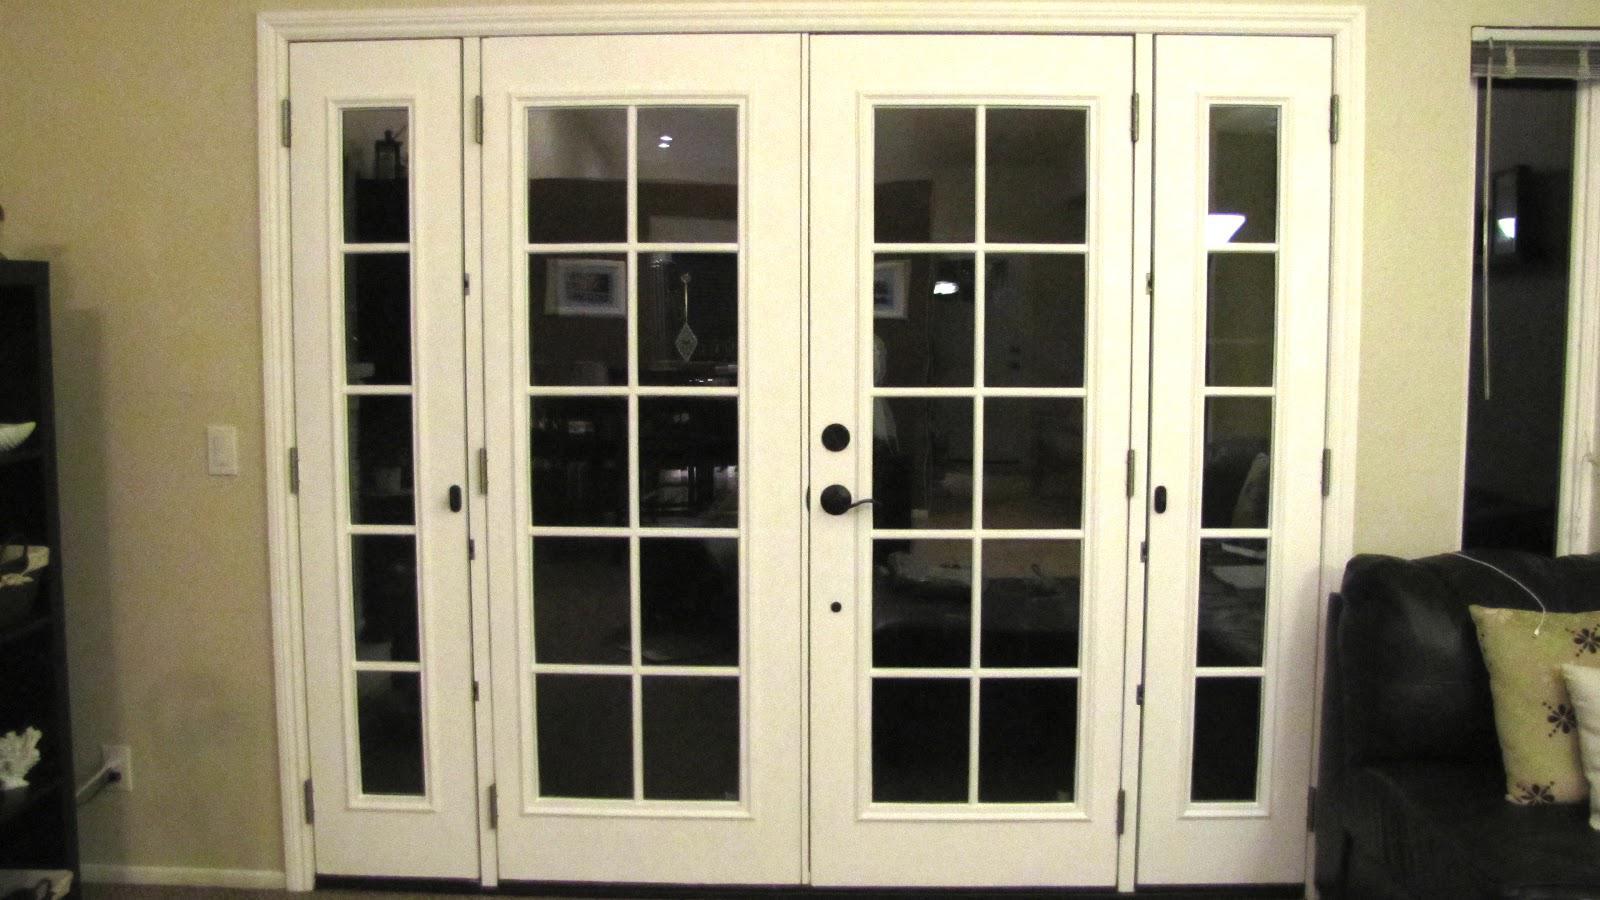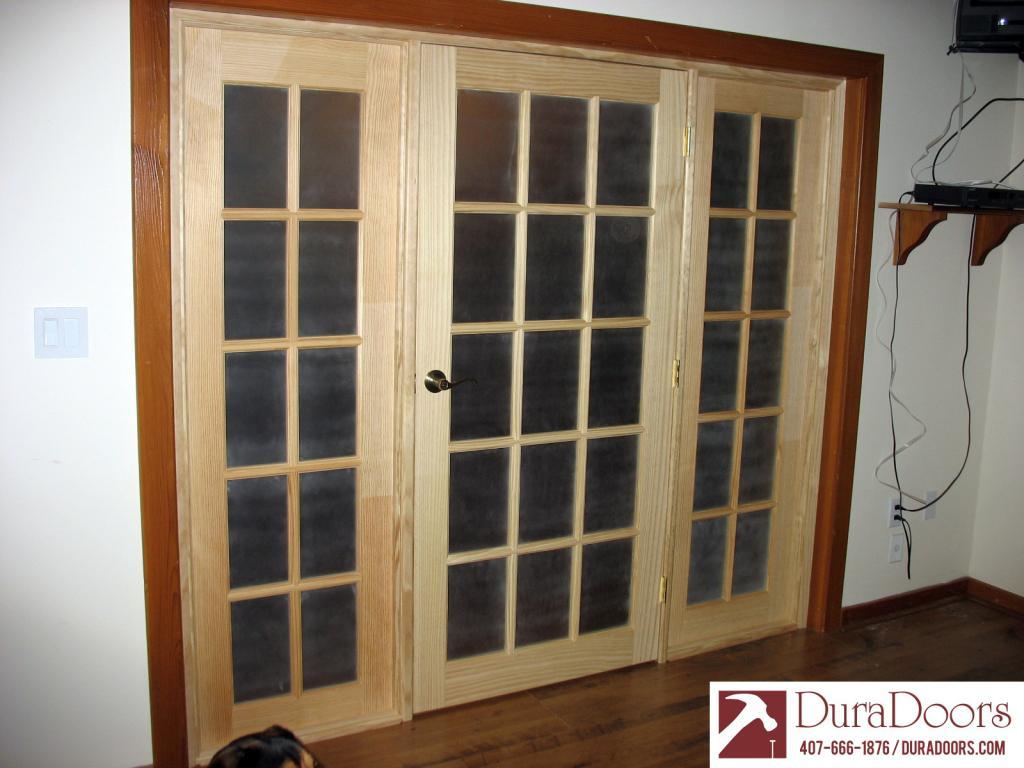The first image is the image on the left, the second image is the image on the right. Evaluate the accuracy of this statement regarding the images: "An image shows a door open wide enough to walk through.". Is it true? Answer yes or no. No. 